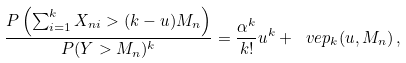Convert formula to latex. <formula><loc_0><loc_0><loc_500><loc_500>\frac { P \left ( \sum _ { i = 1 } ^ { k } X _ { n i } > ( k - u ) M _ { n } \right ) } { P ( Y > M _ { n } ) ^ { k } } = \frac { \alpha ^ { k } } { k ! } u ^ { k } + \ v e p _ { k } ( u , M _ { n } ) \, ,</formula> 